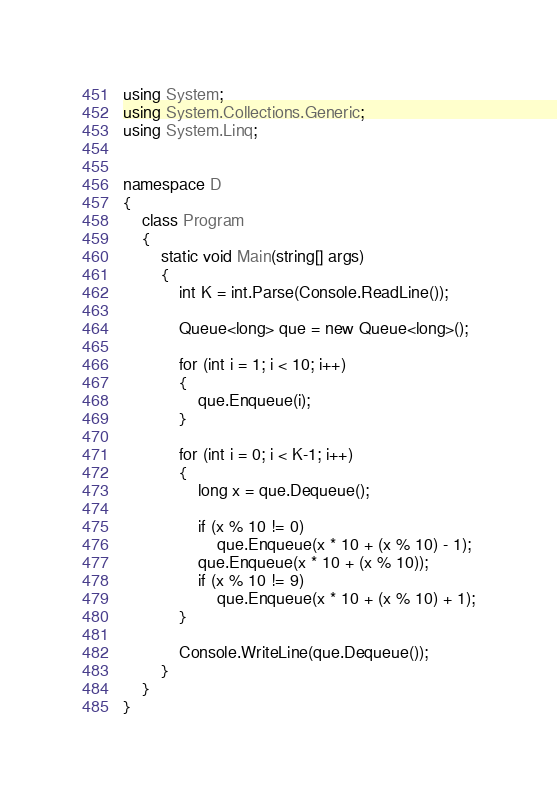Convert code to text. <code><loc_0><loc_0><loc_500><loc_500><_C#_>using System;
using System.Collections.Generic;
using System.Linq;


namespace D
{
	class Program
	{
		static void Main(string[] args)
		{
			int K = int.Parse(Console.ReadLine());

			Queue<long> que = new Queue<long>();

			for (int i = 1; i < 10; i++)
			{
				que.Enqueue(i);
			}

			for (int i = 0; i < K-1; i++)
			{
				long x = que.Dequeue();

				if (x % 10 != 0)
					que.Enqueue(x * 10 + (x % 10) - 1);
				que.Enqueue(x * 10 + (x % 10));
				if (x % 10 != 9)
					que.Enqueue(x * 10 + (x % 10) + 1);
			}

			Console.WriteLine(que.Dequeue());
		}
	}
}
</code> 